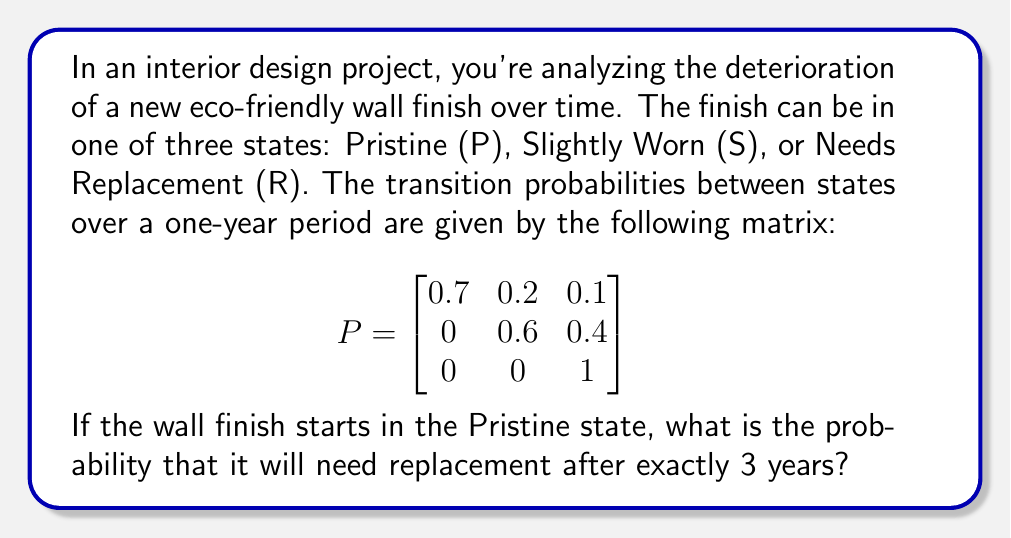Can you solve this math problem? To solve this problem, we need to use the properties of Markov chains:

1) First, we identify the initial state vector. Since the finish starts in the Pristine state, our initial state vector is:

   $$v_0 = \begin{bmatrix} 1 & 0 & 0 \end{bmatrix}$$

2) To find the state after 3 years, we need to multiply the initial state vector by the transition matrix raised to the power of 3:

   $$v_3 = v_0 \cdot P^3$$

3) Let's calculate $P^3$:

   $$P^2 = \begin{bmatrix}
   0.49 & 0.26 & 0.25 \\
   0 & 0.36 & 0.64 \\
   0 & 0 & 1
   \end{bmatrix}$$

   $$P^3 = \begin{bmatrix}
   0.343 & 0.242 & 0.415 \\
   0 & 0.216 & 0.784 \\
   0 & 0 & 1
   \end{bmatrix}$$

4) Now, we multiply $v_0$ by $P^3$:

   $$v_3 = \begin{bmatrix} 1 & 0 & 0 \end{bmatrix} \cdot \begin{bmatrix}
   0.343 & 0.242 & 0.415 \\
   0 & 0.216 & 0.784 \\
   0 & 0 & 1
   \end{bmatrix} = \begin{bmatrix} 0.343 & 0.242 & 0.415 \end{bmatrix}$$

5) The probability of being in the "Needs Replacement" state after 3 years is the third element of this vector: 0.415 or 41.5%.
Answer: 0.415 